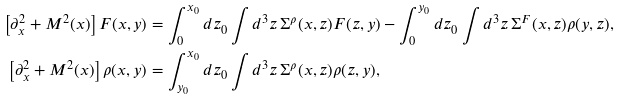Convert formula to latex. <formula><loc_0><loc_0><loc_500><loc_500>\left [ \partial _ { x } ^ { 2 } + M ^ { 2 } ( x ) \right ] F ( x , y ) & = \int _ { 0 } ^ { x _ { 0 } } d z _ { 0 } \int d ^ { 3 } z \, \Sigma ^ { \rho } ( x , z ) F ( z , y ) - \int _ { 0 } ^ { y _ { 0 } } d z _ { 0 } \int d ^ { 3 } z \, \Sigma ^ { F } ( x , z ) \rho ( y , z ) , \\ \left [ \partial _ { x } ^ { 2 } + M ^ { 2 } ( x ) \right ] \rho ( x , y ) & = \int _ { y _ { 0 } } ^ { x _ { 0 } } d z _ { 0 } \int d ^ { 3 } z \, \Sigma ^ { \rho } ( x , z ) \rho ( z , y ) ,</formula> 